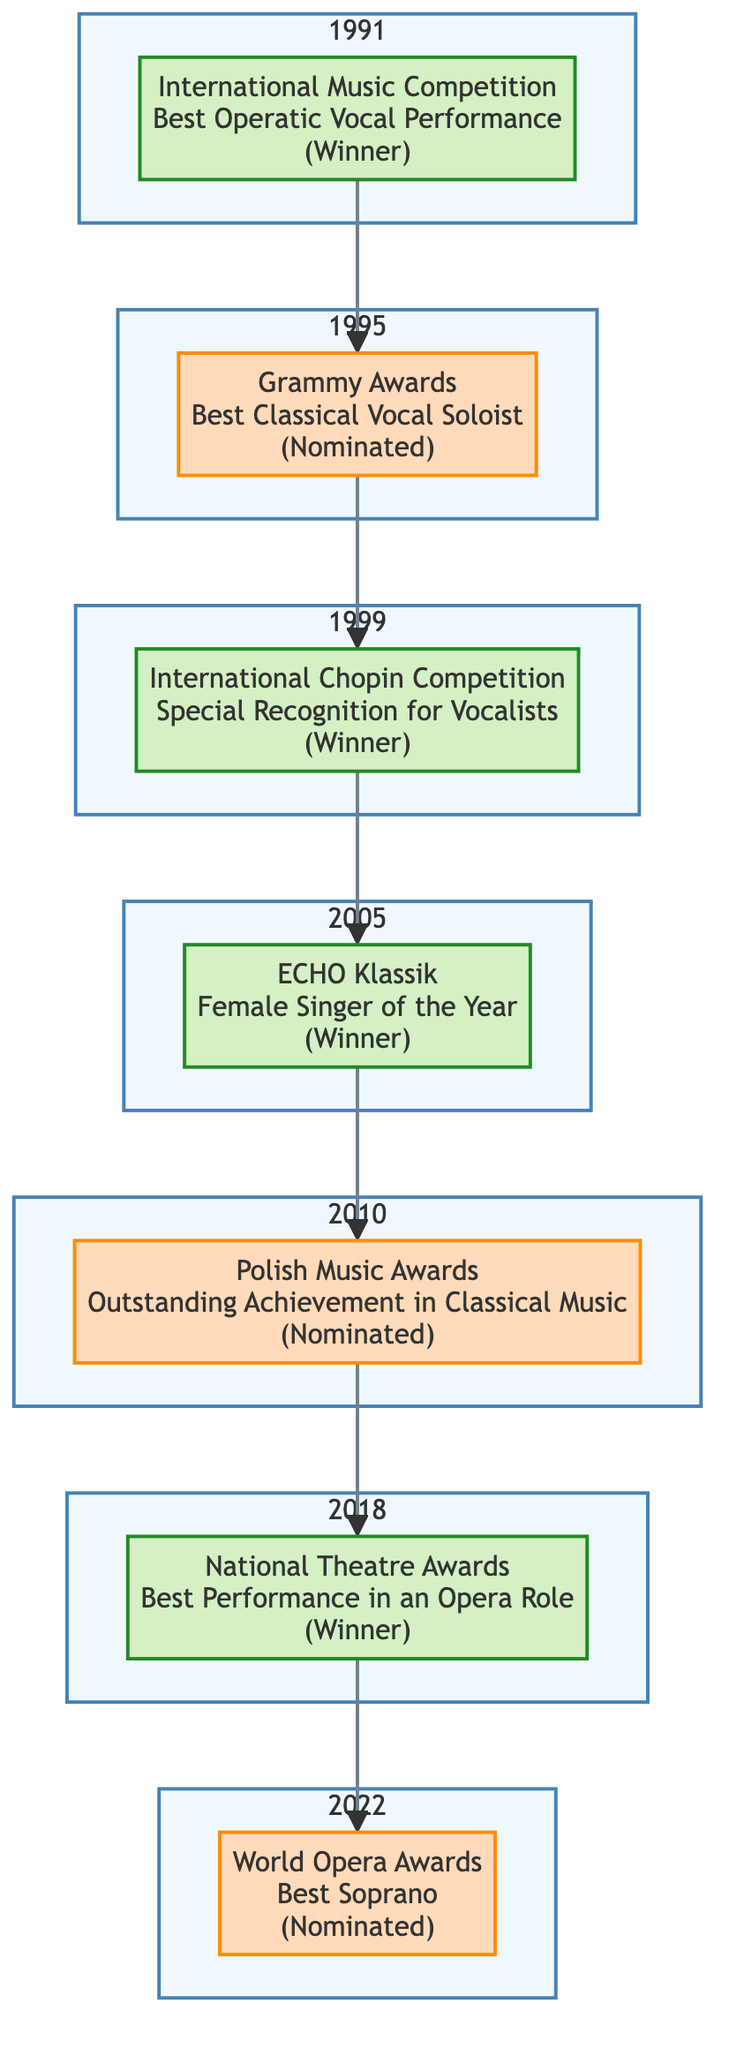What is the earliest award mentioned in the timeline? The diagram shows the timeline starting with 1991 at the top, where the award mentioned is the International Music Competition. Therefore, it is the earliest award in the timeline.
Answer: International Music Competition How many awards did Zofia Kilanowicz win according to the diagram? By analyzing the elements in the diagram, three awards are indicated as "Winners": International Music Competition, International Chopin Competition, and ECHO Klassik. Thus, the total number of wins is three.
Answer: 3 Which year did Zofia receive recognition from the International Chopin Competition? The diagram lists the International Chopin Competition as occurring in 1999, thus that is the year of recognition for that specific award.
Answer: 1999 What category was Zofia Kilanowicz nominated for at the Grammy Awards? According to the diagram, her nomination at the Grammy Awards pertains to the category of Best Classical Vocal Soloist. This is explicitly stated in the relevant node.
Answer: Best Classical Vocal Soloist In which year did Zofia win an award for Best Performance in an Opera Role? The diagram indicates that the National Theatre Awards, for Best Performance in an Opera Role, took place in 2018, which signifies the year when she received the award.
Answer: 2018 Which awards were Zofia Kilanowicz nominated for after her win in 2005? Following her win at the ECHO Klassik in 2005, Zofia received nominations at the Polish Music Awards in 2010 and the World Opera Awards in 2022, as shown by the arrows leading to those nodes.
Answer: Polish Music Awards, World Opera Awards How many total nominations did Zofia Kilanowicz receive according to the diagram? The diagram lists three nominations: Grammy Awards, Polish Music Awards, and World Opera Awards. This adds up to a total of three nominations throughout her career.
Answer: 3 What color indicates a winner in the diagram? The nodes representing winners are filled with a greenish color (#d4f0c4) and outlined with a darker green stroke, which differentiates them from the nominee nodes.
Answer: Greenish color 